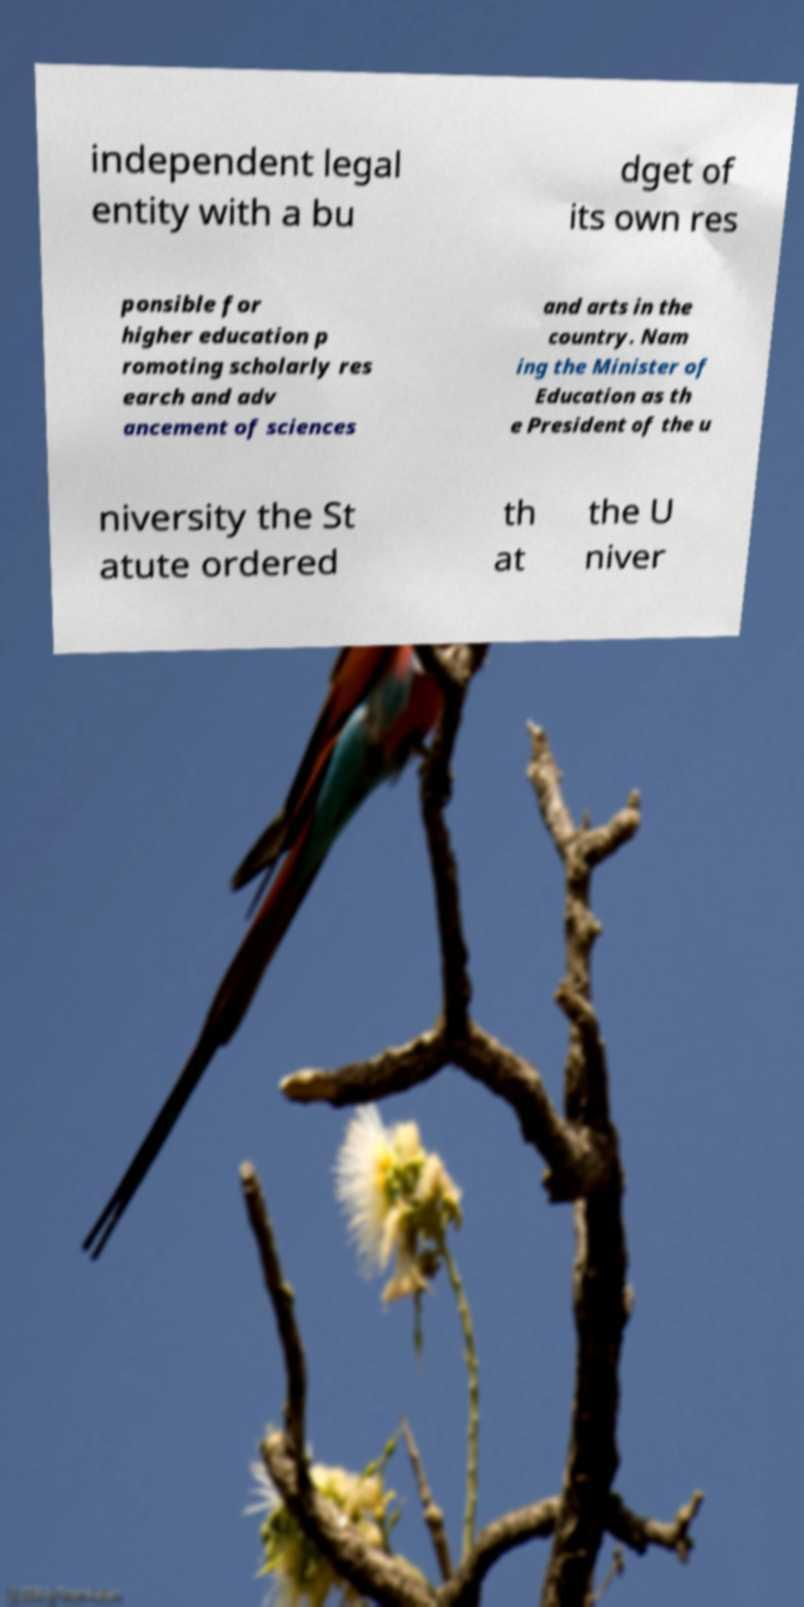There's text embedded in this image that I need extracted. Can you transcribe it verbatim? independent legal entity with a bu dget of its own res ponsible for higher education p romoting scholarly res earch and adv ancement of sciences and arts in the country. Nam ing the Minister of Education as th e President of the u niversity the St atute ordered th at the U niver 